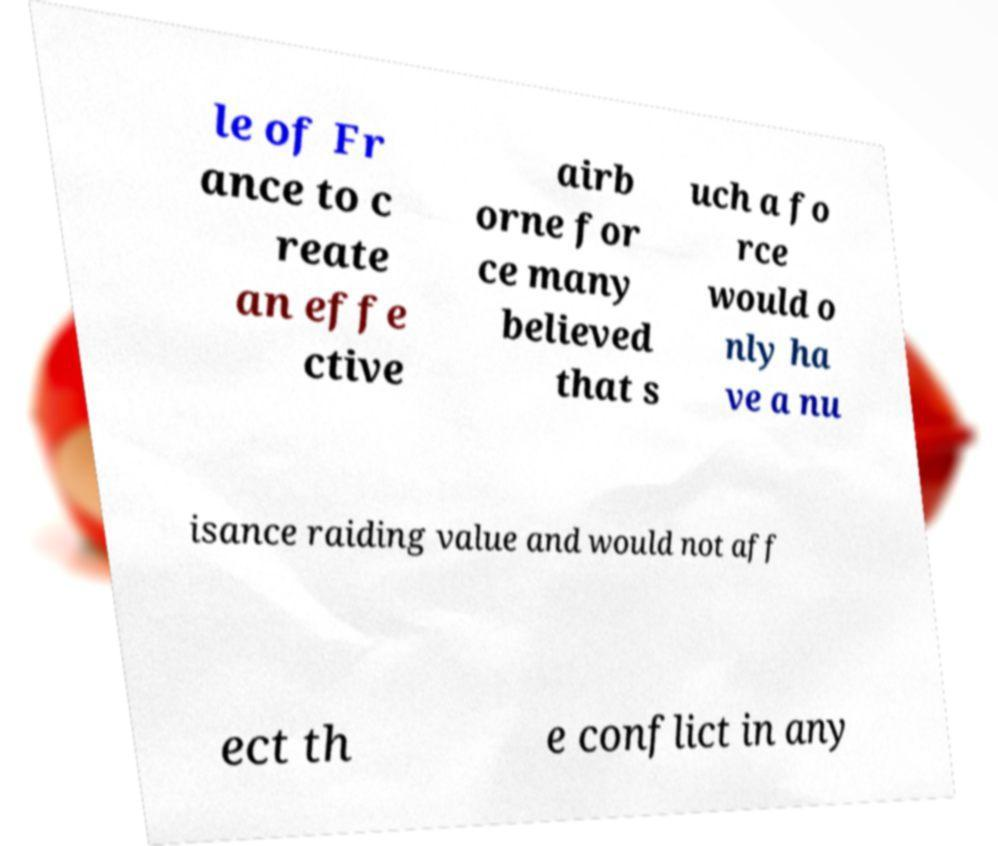Could you extract and type out the text from this image? le of Fr ance to c reate an effe ctive airb orne for ce many believed that s uch a fo rce would o nly ha ve a nu isance raiding value and would not aff ect th e conflict in any 